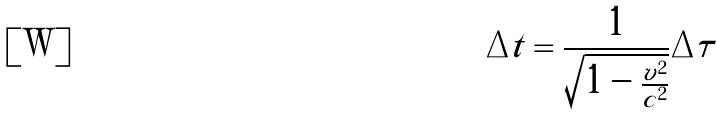Convert formula to latex. <formula><loc_0><loc_0><loc_500><loc_500>\Delta t = \frac { 1 } { \sqrt { 1 - \frac { v ^ { 2 } } { c ^ { 2 } } } } \Delta \tau</formula> 